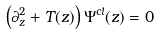<formula> <loc_0><loc_0><loc_500><loc_500>\left ( \partial ^ { 2 } _ { z } + T ( z ) \right ) \Psi ^ { c l } ( z ) = 0</formula> 